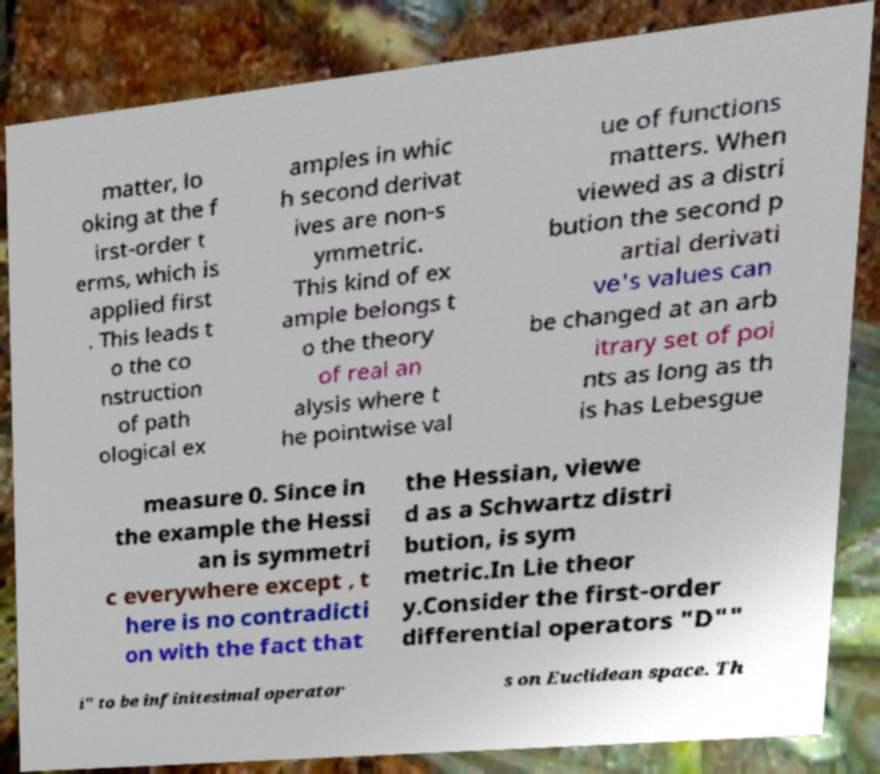There's text embedded in this image that I need extracted. Can you transcribe it verbatim? matter, lo oking at the f irst-order t erms, which is applied first . This leads t o the co nstruction of path ological ex amples in whic h second derivat ives are non-s ymmetric. This kind of ex ample belongs t o the theory of real an alysis where t he pointwise val ue of functions matters. When viewed as a distri bution the second p artial derivati ve's values can be changed at an arb itrary set of poi nts as long as th is has Lebesgue measure 0. Since in the example the Hessi an is symmetri c everywhere except , t here is no contradicti on with the fact that the Hessian, viewe d as a Schwartz distri bution, is sym metric.In Lie theor y.Consider the first-order differential operators "D"" i" to be infinitesimal operator s on Euclidean space. Th 